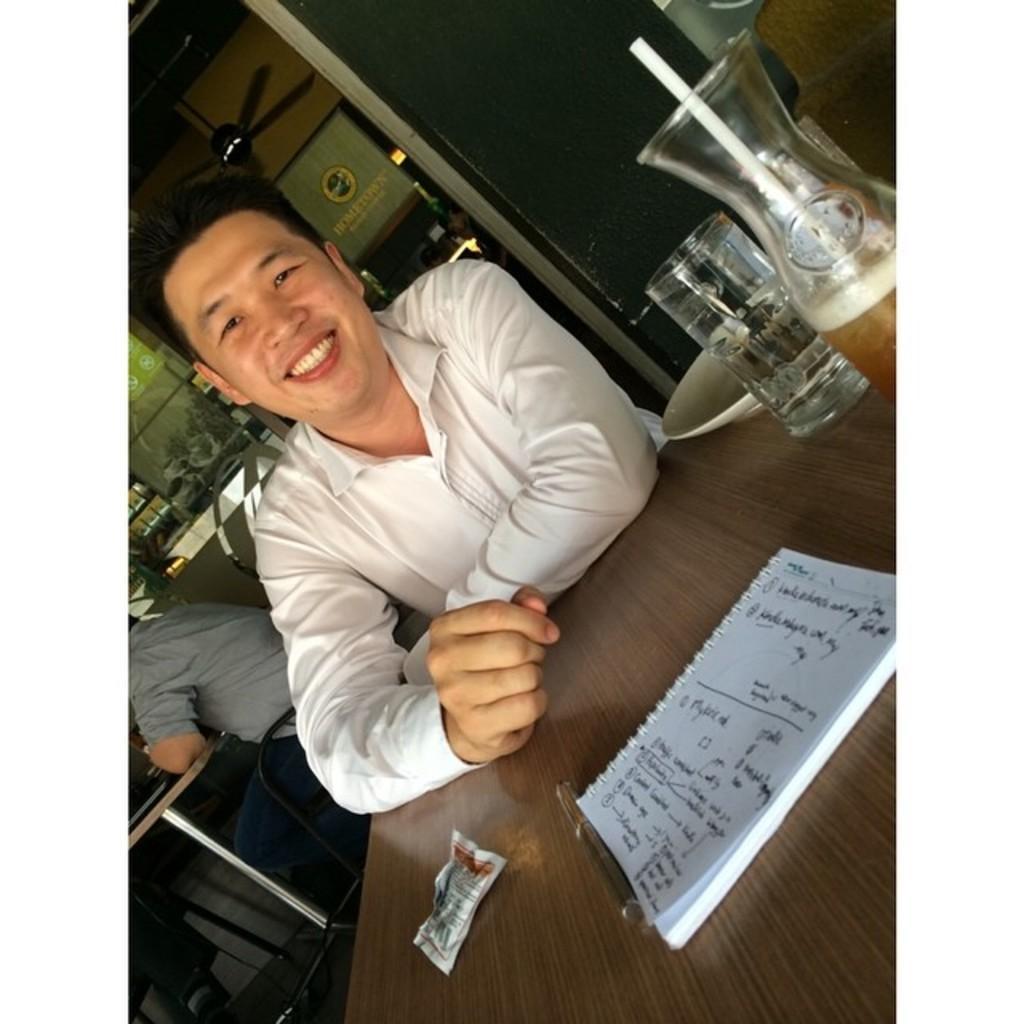Could you give a brief overview of what you see in this image? A person is sitting on a chair and smiling, wore white shirt. In-front of this person there is a table, on a table there is a capsule, book, pen, plate, glass of water and a bottle with straw. At the background there is a fan attached to the rooftop and other person is sitting on a chair. In-front of this person there is a table. 